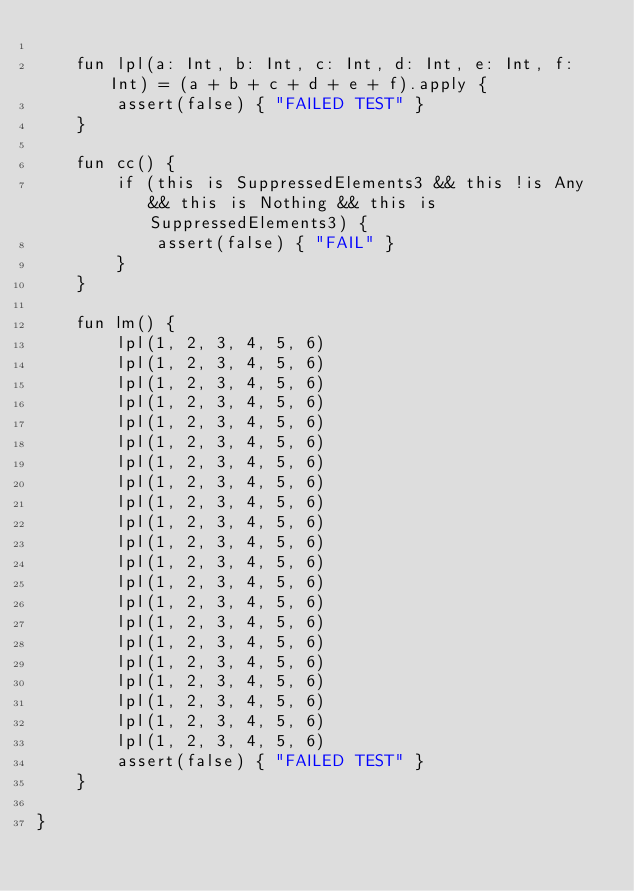Convert code to text. <code><loc_0><loc_0><loc_500><loc_500><_Kotlin_>
    fun lpl(a: Int, b: Int, c: Int, d: Int, e: Int, f: Int) = (a + b + c + d + e + f).apply {
        assert(false) { "FAILED TEST" }
    }

    fun cc() {
        if (this is SuppressedElements3 && this !is Any && this is Nothing && this is SuppressedElements3) {
            assert(false) { "FAIL" }
        }
    }

    fun lm() {
        lpl(1, 2, 3, 4, 5, 6)
        lpl(1, 2, 3, 4, 5, 6)
        lpl(1, 2, 3, 4, 5, 6)
        lpl(1, 2, 3, 4, 5, 6)
        lpl(1, 2, 3, 4, 5, 6)
        lpl(1, 2, 3, 4, 5, 6)
        lpl(1, 2, 3, 4, 5, 6)
        lpl(1, 2, 3, 4, 5, 6)
        lpl(1, 2, 3, 4, 5, 6)
        lpl(1, 2, 3, 4, 5, 6)
        lpl(1, 2, 3, 4, 5, 6)
        lpl(1, 2, 3, 4, 5, 6)
        lpl(1, 2, 3, 4, 5, 6)
        lpl(1, 2, 3, 4, 5, 6)
        lpl(1, 2, 3, 4, 5, 6)
        lpl(1, 2, 3, 4, 5, 6)
        lpl(1, 2, 3, 4, 5, 6)
        lpl(1, 2, 3, 4, 5, 6)
        lpl(1, 2, 3, 4, 5, 6)
        lpl(1, 2, 3, 4, 5, 6)
        lpl(1, 2, 3, 4, 5, 6)
        assert(false) { "FAILED TEST" }
    }

}
</code> 